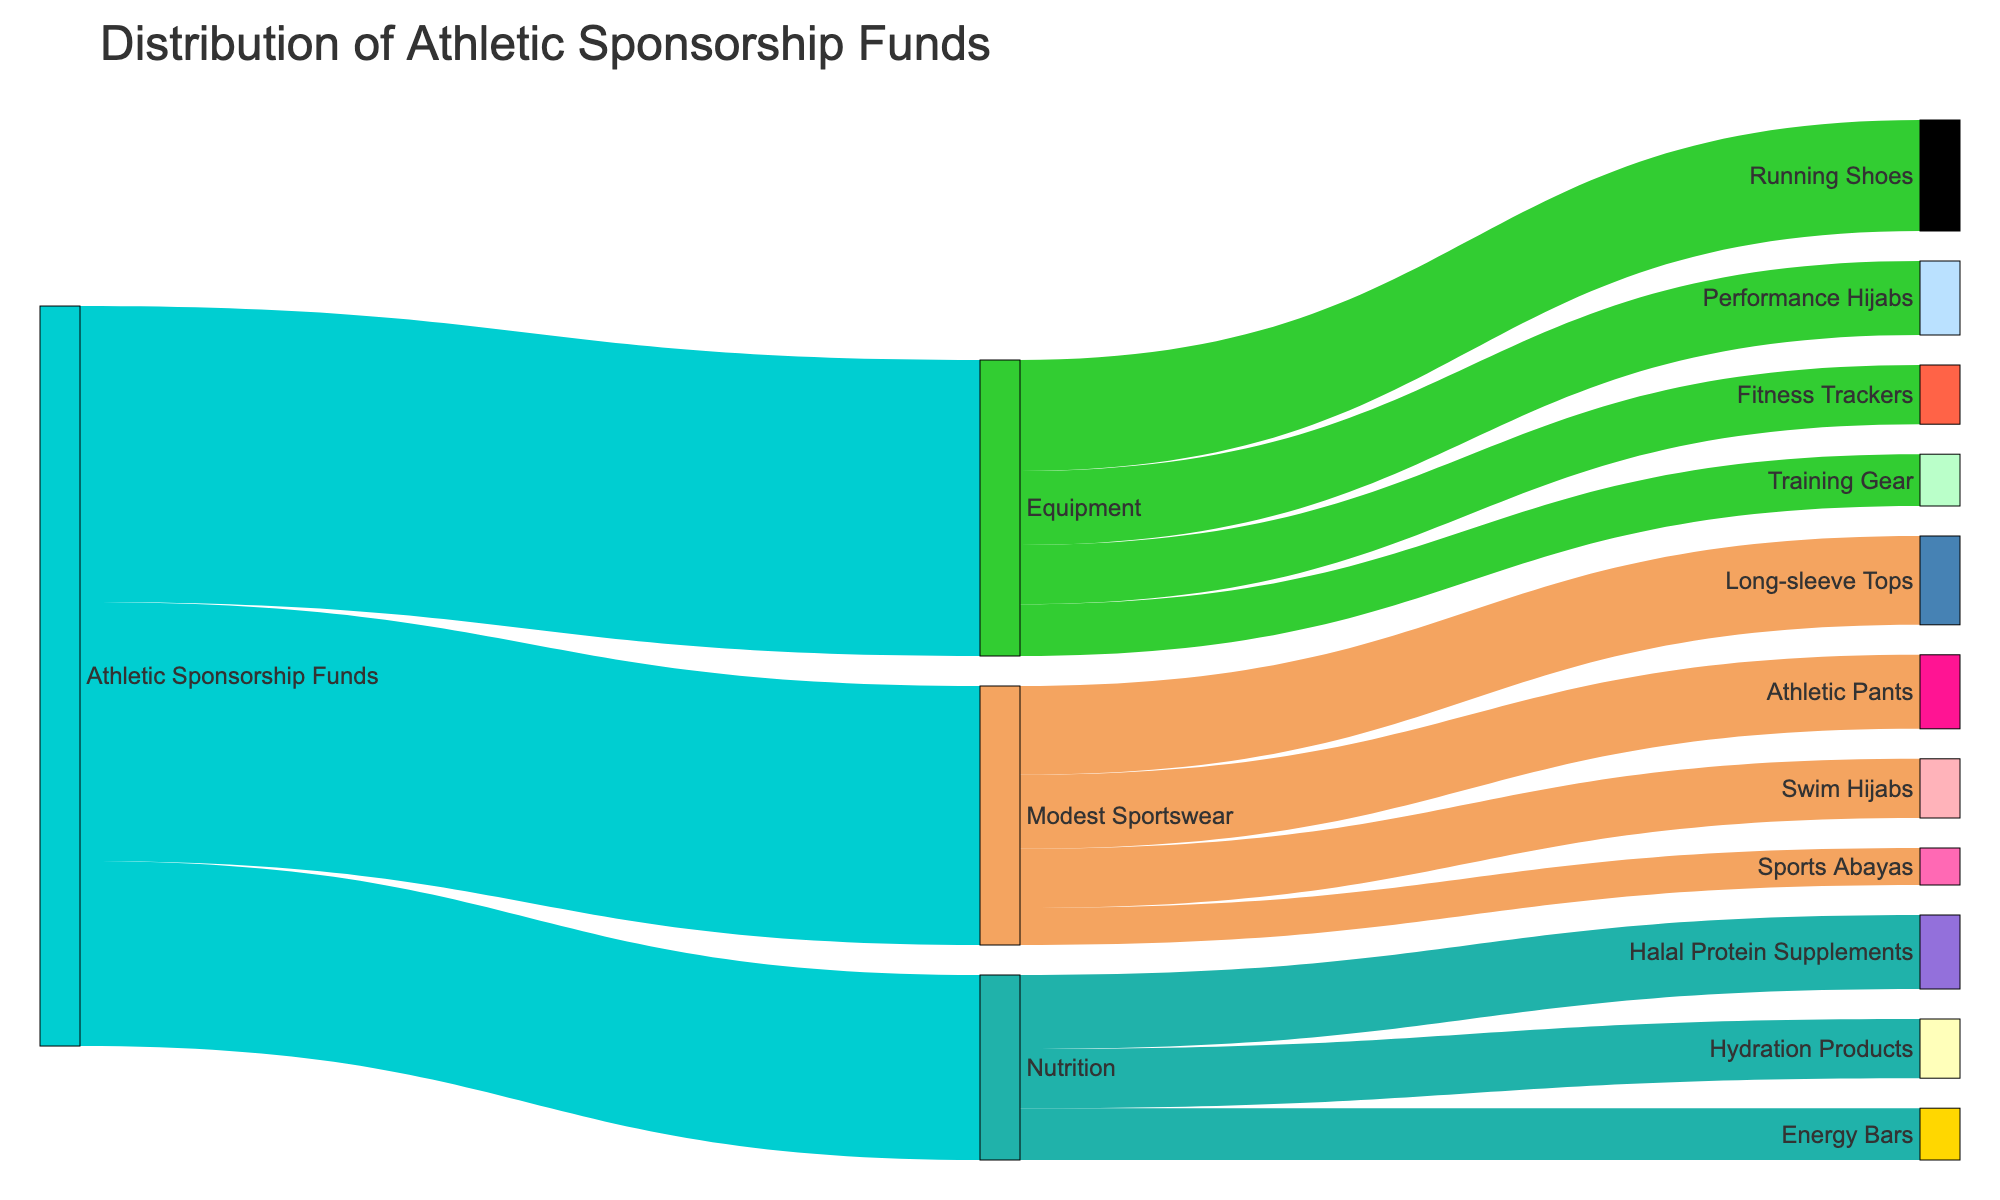What's the title of the figure? The title is displayed at the top of the figure, indicating the overall subject of the diagram.
Answer: Distribution of Athletic Sponsorship Funds Which category received the most funds from the athletic sponsorship? By looking at the size of the flow from "Athletic Sponsorship Funds" to the various categories, you can see which has the largest value.
Answer: Equipment How much funding was allocated to Halal Protein Supplements? Follow the flow from "Nutrition" to "Halal Protein Supplements" and look at the numeric value associated with it.
Answer: 100,000 How much more funding did Long-sleeve Tops receive compared to Sports Abayas? Find the values for both Long-sleeve Tops and Sports Abayas, then subtract the smaller from the larger.
Answer: 70,000 What is the total funding allocated to Nutrition-related items? Add up the values for all items under the "Nutrition" category: Halal Protein Supplements, Hydration Products, and Energy Bars.
Answer: 250,000 Which equipment item received the least amount of funding? Within the "Equipment" category, identify the item with the smallest flow value.
Answer: Training Gear If the total sponsorship funds are 1,000,000, what percentage of the funds was allocated to Modest Sportswear? Divide the funds for Modest Sportswear by the total funds and multiply by 100 to find the percentage.
Answer: 35% Are there any categories where one specific sub-item received more than 50% of the category's total funding? Check the sub-items under each category to see if any exceed half of their total category value.
Answer: No Compare the funding allocated to Performance Hijabs and Swim Hijabs. Which one received more? Look at the values next to each item and compare them directly.
Answer: Performance Hijabs What is the combined funding for all items under Equipment and Modest Sportswear? Sum all values under the "Equipment" and "Modest Sportswear" categories.
Answer: 750,000 